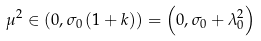Convert formula to latex. <formula><loc_0><loc_0><loc_500><loc_500>\mu ^ { 2 } \in \left ( 0 , \sigma _ { 0 } \left ( 1 + k \right ) \right ) = \left ( 0 , \sigma _ { 0 } + \lambda _ { 0 } ^ { 2 } \right )</formula> 